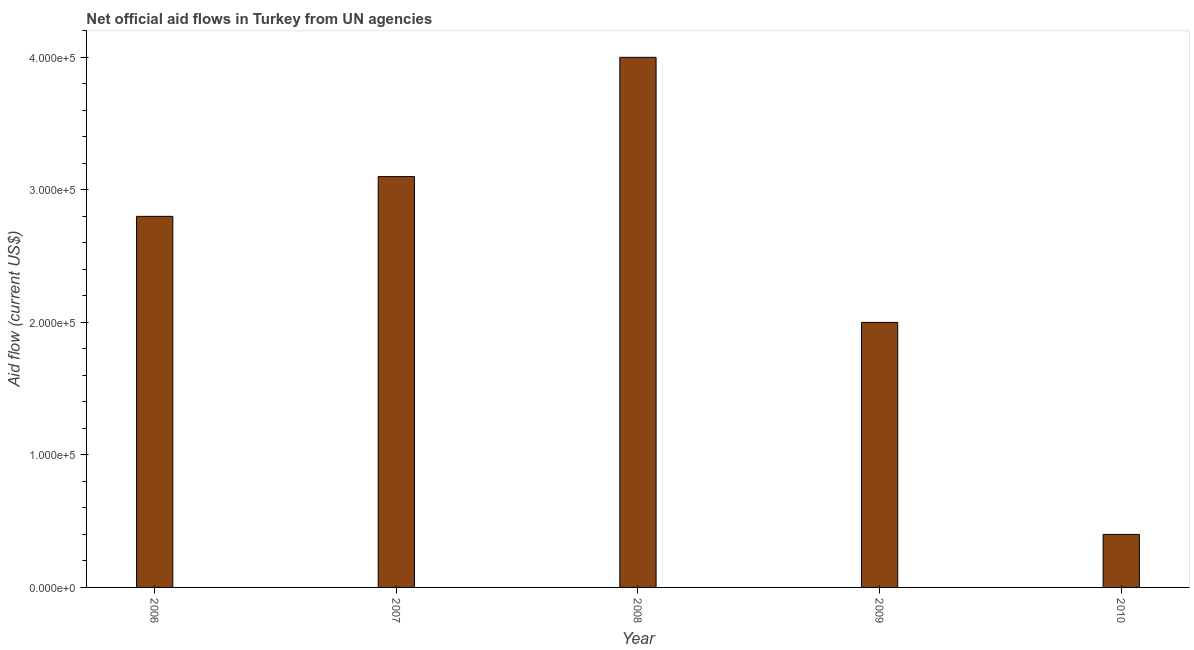Does the graph contain grids?
Offer a terse response. No. What is the title of the graph?
Make the answer very short. Net official aid flows in Turkey from UN agencies. What is the label or title of the X-axis?
Provide a short and direct response. Year. What is the net official flows from un agencies in 2009?
Offer a very short reply. 2.00e+05. Across all years, what is the maximum net official flows from un agencies?
Provide a short and direct response. 4.00e+05. Across all years, what is the minimum net official flows from un agencies?
Provide a succinct answer. 4.00e+04. In which year was the net official flows from un agencies minimum?
Give a very brief answer. 2010. What is the sum of the net official flows from un agencies?
Provide a short and direct response. 1.23e+06. What is the difference between the net official flows from un agencies in 2006 and 2007?
Offer a very short reply. -3.00e+04. What is the average net official flows from un agencies per year?
Offer a very short reply. 2.46e+05. In how many years, is the net official flows from un agencies greater than 100000 US$?
Give a very brief answer. 4. Do a majority of the years between 2009 and 2006 (inclusive) have net official flows from un agencies greater than 20000 US$?
Give a very brief answer. Yes. Is the difference between the net official flows from un agencies in 2007 and 2008 greater than the difference between any two years?
Your response must be concise. No. In how many years, is the net official flows from un agencies greater than the average net official flows from un agencies taken over all years?
Provide a succinct answer. 3. Are all the bars in the graph horizontal?
Provide a succinct answer. No. How many years are there in the graph?
Keep it short and to the point. 5. What is the difference between two consecutive major ticks on the Y-axis?
Your answer should be very brief. 1.00e+05. What is the Aid flow (current US$) in 2006?
Provide a succinct answer. 2.80e+05. What is the Aid flow (current US$) of 2008?
Offer a very short reply. 4.00e+05. What is the Aid flow (current US$) of 2009?
Provide a short and direct response. 2.00e+05. What is the Aid flow (current US$) in 2010?
Give a very brief answer. 4.00e+04. What is the difference between the Aid flow (current US$) in 2006 and 2007?
Keep it short and to the point. -3.00e+04. What is the difference between the Aid flow (current US$) in 2006 and 2008?
Offer a very short reply. -1.20e+05. What is the difference between the Aid flow (current US$) in 2006 and 2009?
Provide a succinct answer. 8.00e+04. What is the difference between the Aid flow (current US$) in 2007 and 2009?
Keep it short and to the point. 1.10e+05. What is the difference between the Aid flow (current US$) in 2007 and 2010?
Your answer should be compact. 2.70e+05. What is the difference between the Aid flow (current US$) in 2008 and 2009?
Make the answer very short. 2.00e+05. What is the ratio of the Aid flow (current US$) in 2006 to that in 2007?
Ensure brevity in your answer.  0.9. What is the ratio of the Aid flow (current US$) in 2006 to that in 2008?
Give a very brief answer. 0.7. What is the ratio of the Aid flow (current US$) in 2006 to that in 2009?
Your response must be concise. 1.4. What is the ratio of the Aid flow (current US$) in 2006 to that in 2010?
Your answer should be compact. 7. What is the ratio of the Aid flow (current US$) in 2007 to that in 2008?
Make the answer very short. 0.78. What is the ratio of the Aid flow (current US$) in 2007 to that in 2009?
Your answer should be compact. 1.55. What is the ratio of the Aid flow (current US$) in 2007 to that in 2010?
Keep it short and to the point. 7.75. What is the ratio of the Aid flow (current US$) in 2008 to that in 2009?
Make the answer very short. 2. 